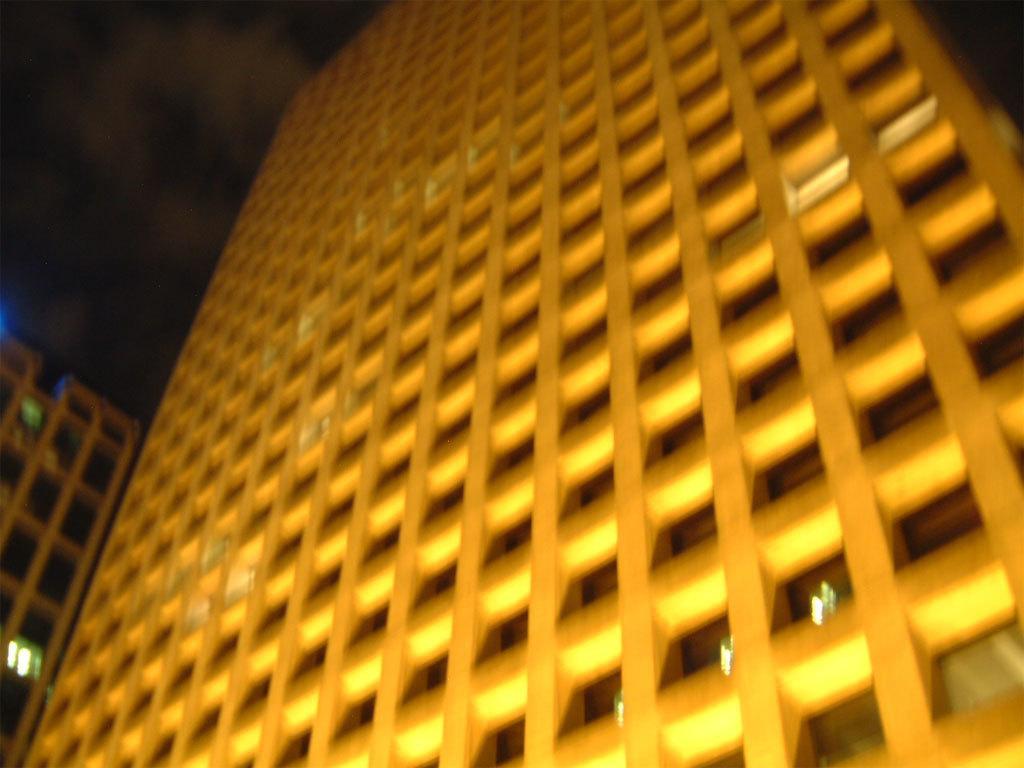Describe this image in one or two sentences. In this image I can see the buildings. In the background I can see the clouds and the sky. 